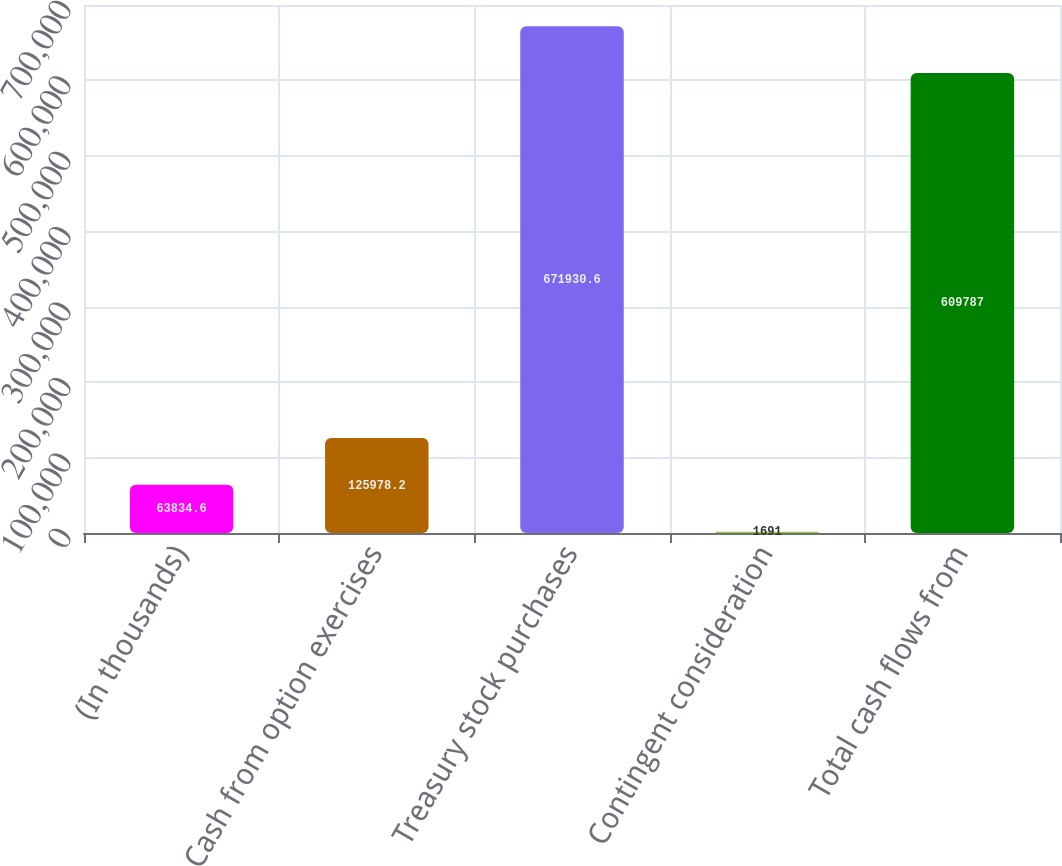Convert chart to OTSL. <chart><loc_0><loc_0><loc_500><loc_500><bar_chart><fcel>(In thousands)<fcel>Cash from option exercises<fcel>Treasury stock purchases<fcel>Contingent consideration<fcel>Total cash flows from<nl><fcel>63834.6<fcel>125978<fcel>671931<fcel>1691<fcel>609787<nl></chart> 